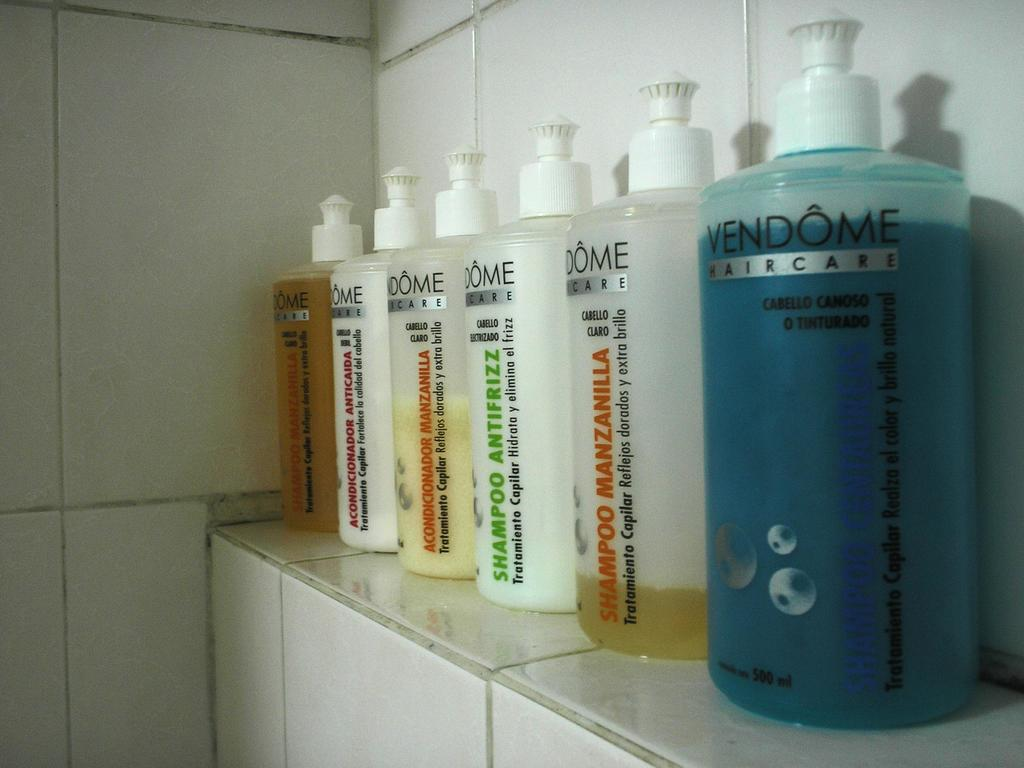Provide a one-sentence caption for the provided image. bottles of Vendome Haircare lined up on a bathroom shelf. 